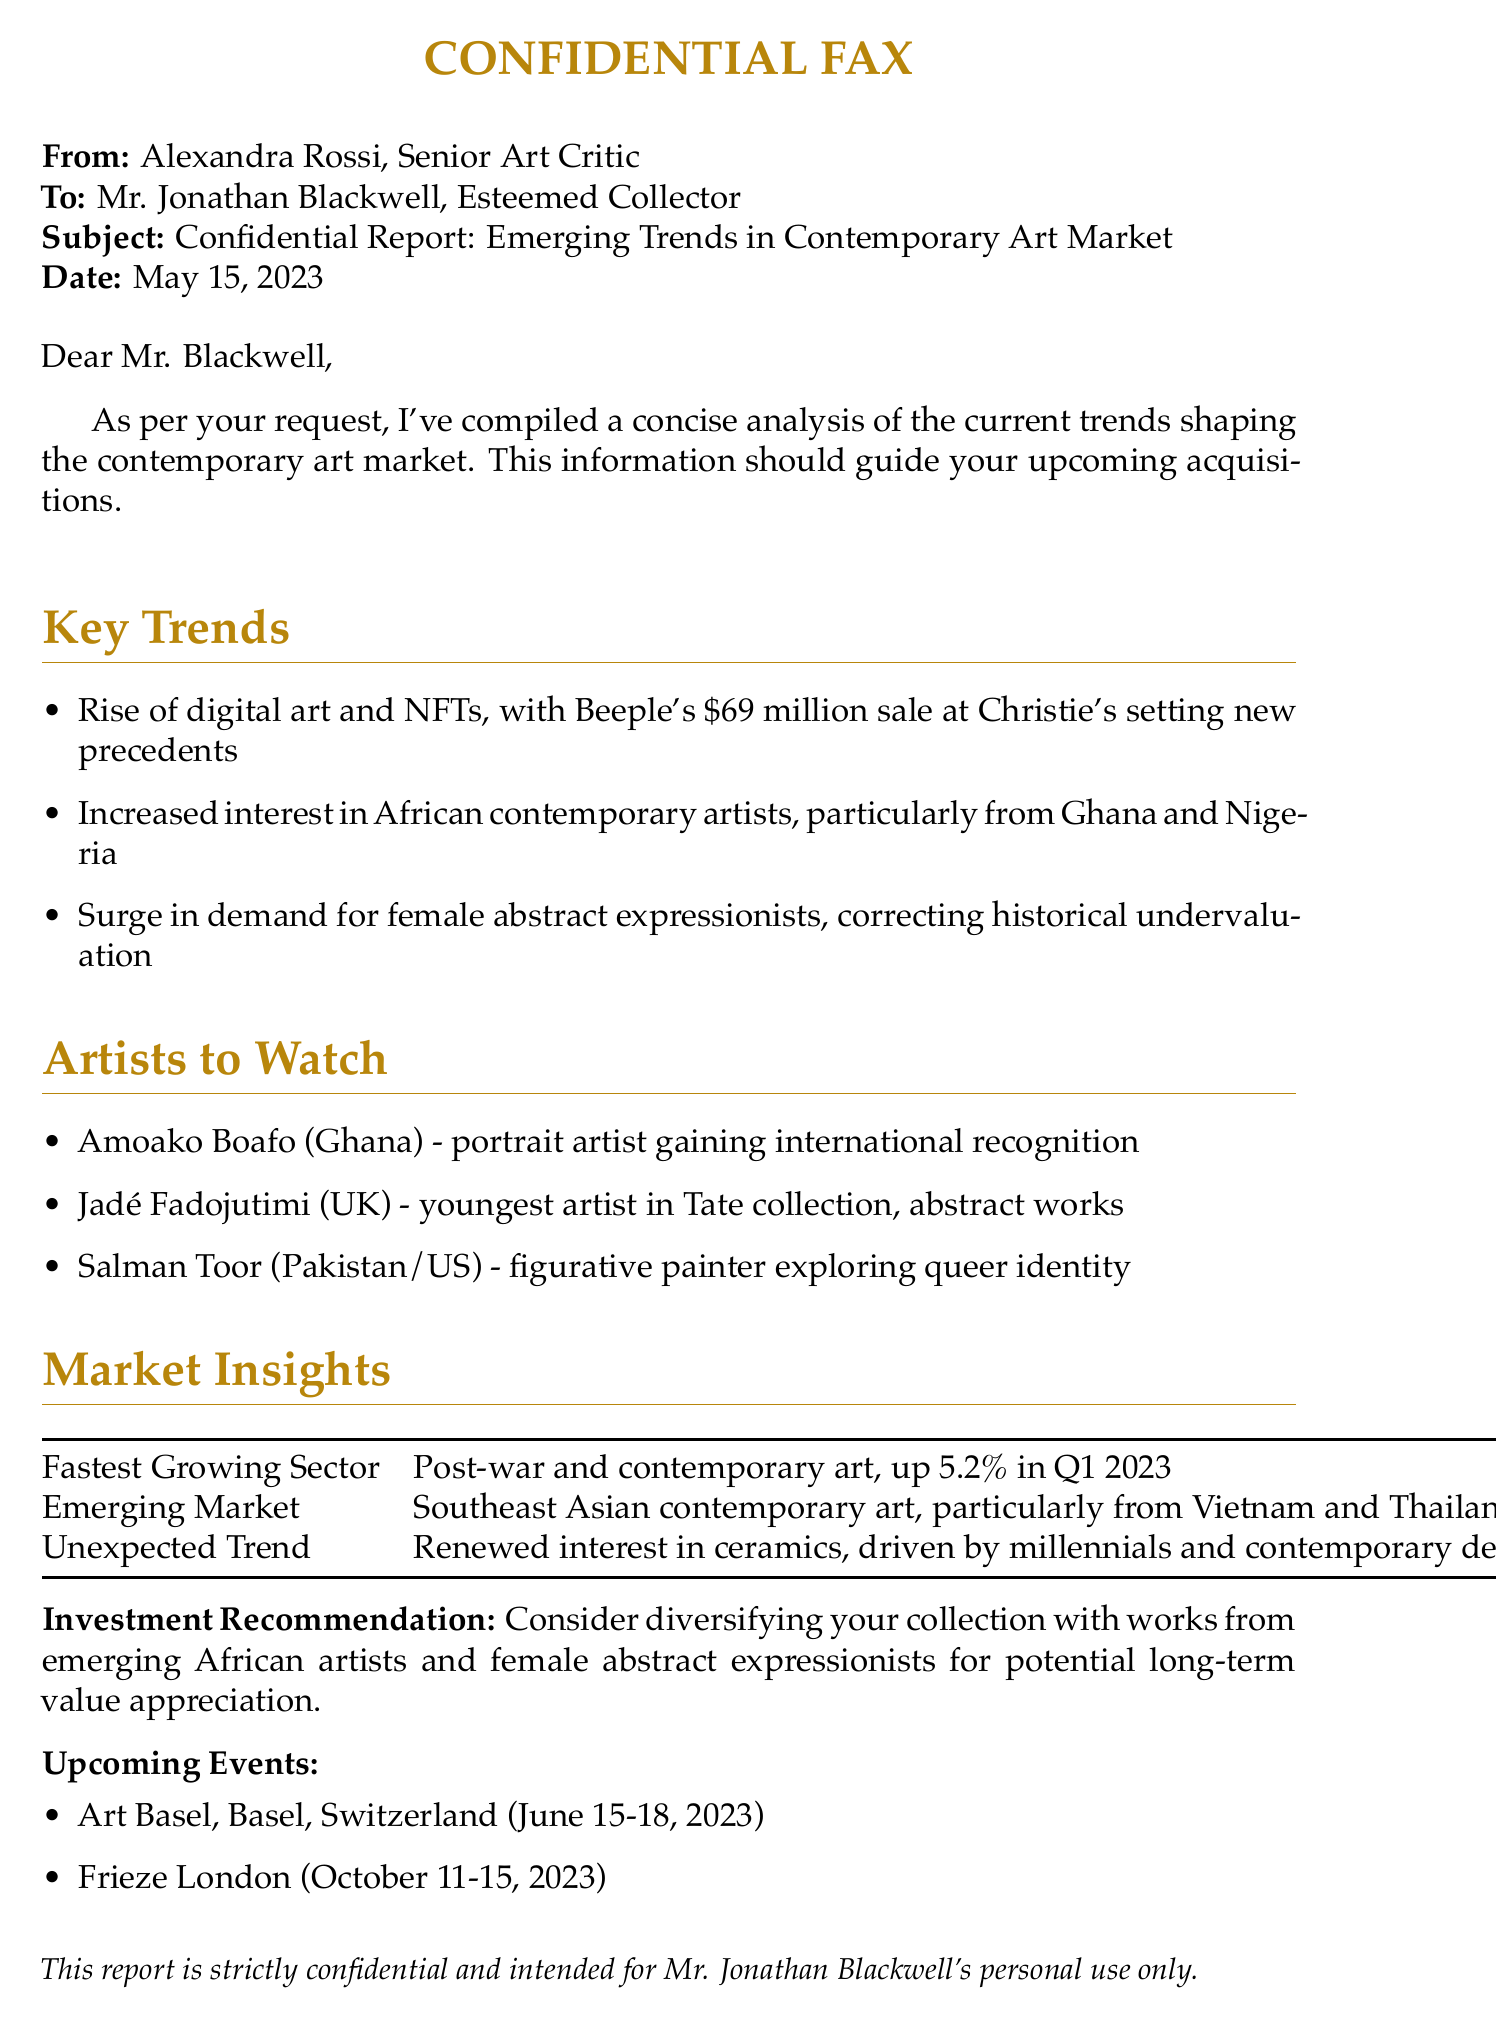What is the main subject of the fax? The main subject of the fax is a confidential report analyzing emerging trends in the contemporary art market.
Answer: Confidential Report: Emerging Trends in Contemporary Art Market Who is the sender of the fax? The sender of the fax is the senior art critic who compiled the report.
Answer: Alexandra Rossi What is the date of the report? The date indicates when the report was sent.
Answer: May 15, 2023 What is one emerging market for contemporary art mentioned in the report? The report specifies a region that is becoming popular in the contemporary art scene.
Answer: Southeast Asian contemporary art Which artist from Ghana is highlighted in the report? The report mentions an artist who is gaining recognition in portrait painting.
Answer: Amoako Boafo What is the fastest growing sector in the art market according to the report? The report identifies a specific sector that has seen significant growth recently.
Answer: Post-war and contemporary art What investment recommendation is made in the report? The report gives advice on the type of artists to include in a collection for potential value appreciation.
Answer: Diversifying with emerging African artists and female abstract expressionists What upcoming event is scheduled for June 2023? The report lists major art events that are forthcoming, specifying one in June.
Answer: Art Basel, Basel, Switzerland Which artist is recognized as the youngest in the Tate collection? The report identifies an artist known for her abstract works and youth in the significant collection.
Answer: Jadé Fadojutimi 